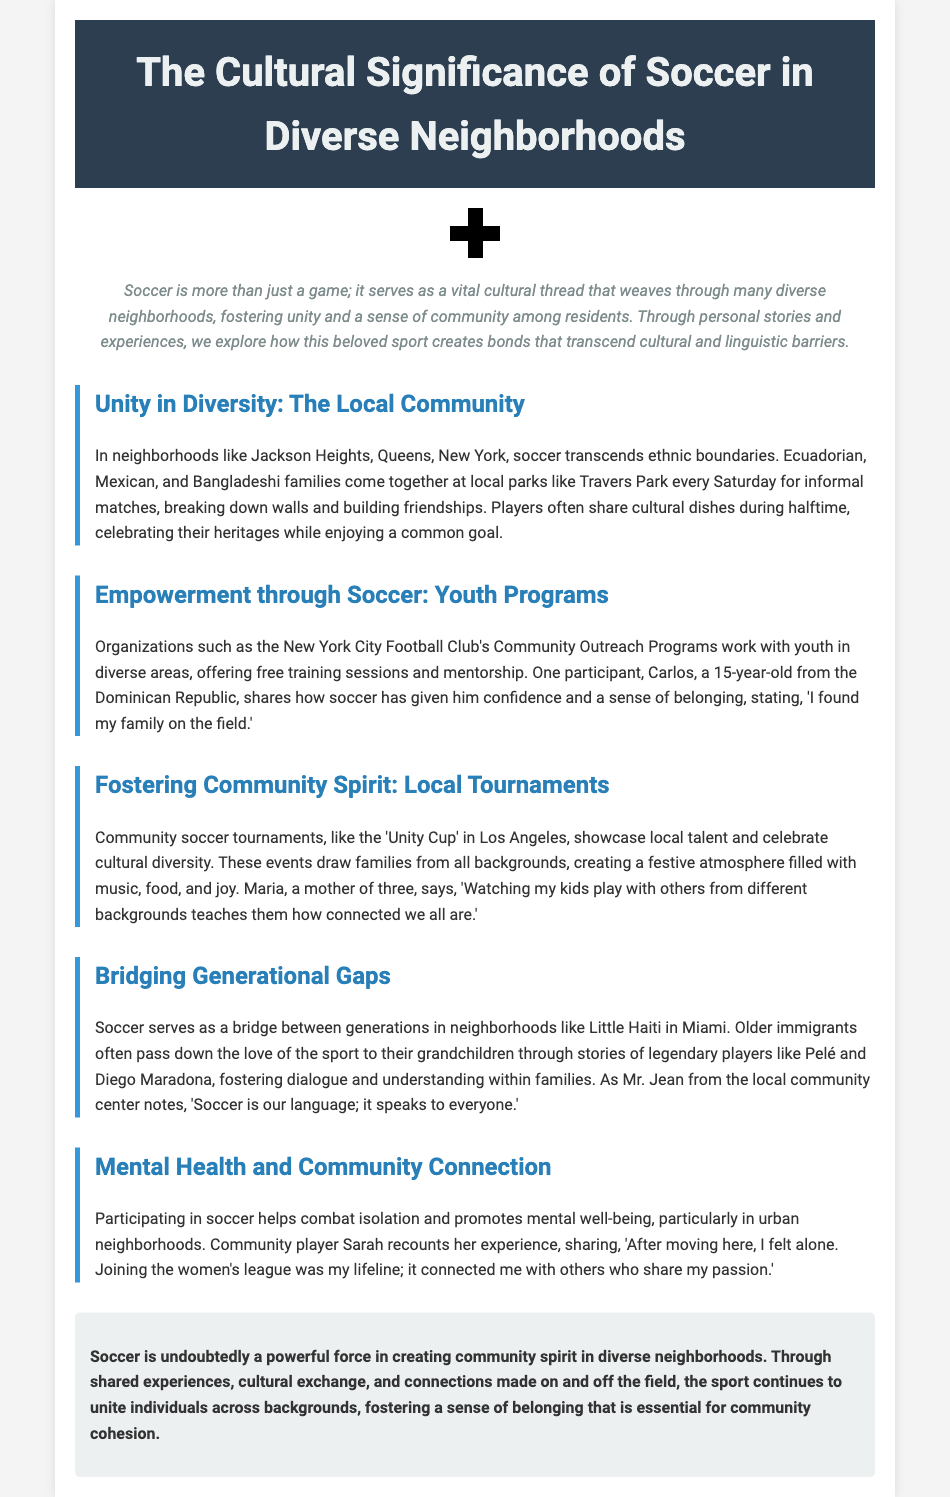What neighborhood is highlighted for its diverse soccer community? The document mentions Jackson Heights in Queens, New York, as a neighborhood fostering a diverse soccer community.
Answer: Jackson Heights Who shares their experience about finding confidence on the field? The document includes a personal story from Carlos, who is a participant in youth soccer programs.
Answer: Carlos What tournament is mentioned that celebrates cultural diversity? The document references a community soccer tournament called the 'Unity Cup' held in Los Angeles, which highlights local talent.
Answer: Unity Cup Which immigrant community is noted for bridging generational gaps through soccer? The document highlights the Little Haiti community in Miami as a place where older immigrants share their love of soccer with grandchildren.
Answer: Little Haiti How does Sarah describe her experience with joining the women's league? Sarah recounts that joining the women's league was crucial in connecting her with others after feeling alone in her new neighborhood.
Answer: Lifeline 